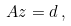<formula> <loc_0><loc_0><loc_500><loc_500>A z = d \, ,</formula> 